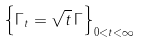Convert formula to latex. <formula><loc_0><loc_0><loc_500><loc_500>\left \{ \Gamma _ { t } = \sqrt { t } \, \Gamma \right \} _ { 0 < t < \infty }</formula> 